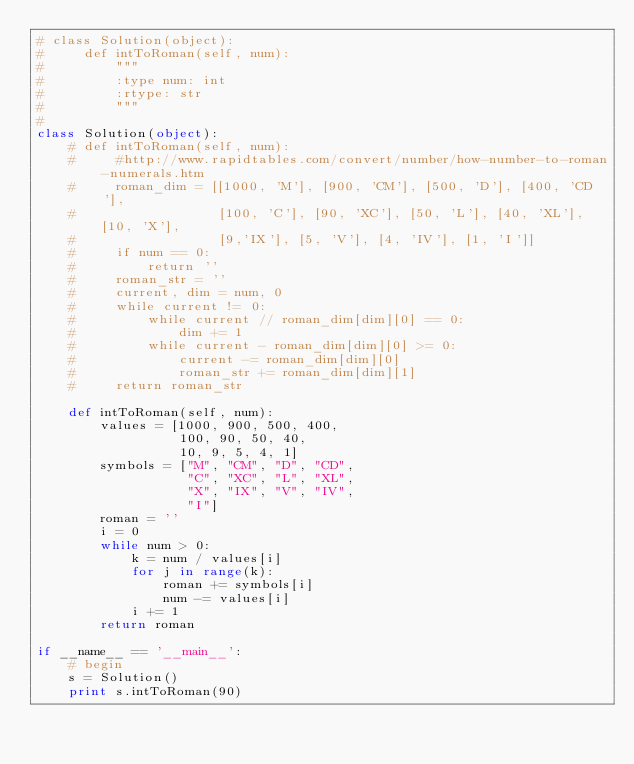Convert code to text. <code><loc_0><loc_0><loc_500><loc_500><_Python_># class Solution(object):
#     def intToRoman(self, num):
#         """
#         :type num: int
#         :rtype: str
#         """
#
class Solution(object):
    # def intToRoman(self, num):
    #     #http://www.rapidtables.com/convert/number/how-number-to-roman-numerals.htm
    #     roman_dim = [[1000, 'M'], [900, 'CM'], [500, 'D'], [400, 'CD'],
    #                  [100, 'C'], [90, 'XC'], [50, 'L'], [40, 'XL'], [10, 'X'],
    #                  [9,'IX'], [5, 'V'], [4, 'IV'], [1, 'I']]
    #     if num == 0:
    #         return ''
    #     roman_str = ''
    #     current, dim = num, 0
    #     while current != 0:
    #         while current // roman_dim[dim][0] == 0:
    #             dim += 1
    #         while current - roman_dim[dim][0] >= 0:
    #             current -= roman_dim[dim][0]
    #             roman_str += roman_dim[dim][1]
    #     return roman_str

    def intToRoman(self, num):
        values = [1000, 900, 500, 400,
                  100, 90, 50, 40,
                  10, 9, 5, 4, 1]
        symbols = ["M", "CM", "D", "CD",
                   "C", "XC", "L", "XL",
                   "X", "IX", "V", "IV",
                   "I"]
        roman = ''
        i = 0
        while num > 0:
            k = num / values[i]
            for j in range(k):
                roman += symbols[i]
                num -= values[i]
            i += 1
        return roman

if __name__ == '__main__':
    # begin
    s = Solution()
    print s.intToRoman(90)</code> 